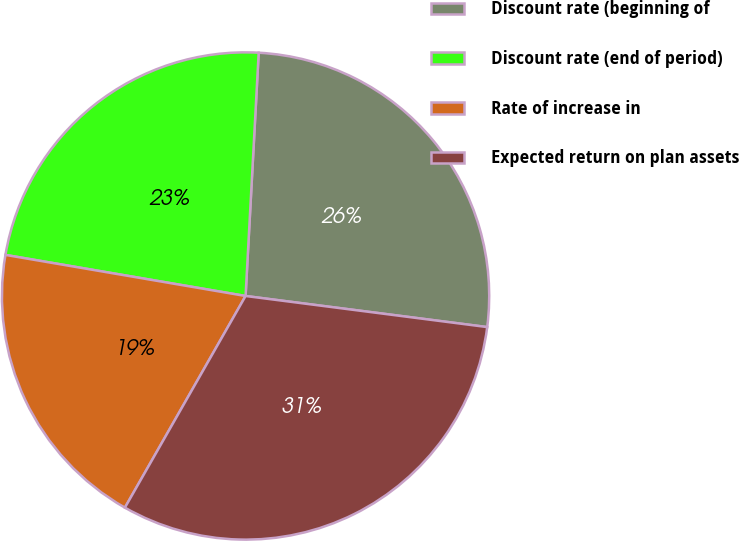<chart> <loc_0><loc_0><loc_500><loc_500><pie_chart><fcel>Discount rate (beginning of<fcel>Discount rate (end of period)<fcel>Rate of increase in<fcel>Expected return on plan assets<nl><fcel>26.18%<fcel>23.16%<fcel>19.45%<fcel>31.21%<nl></chart> 